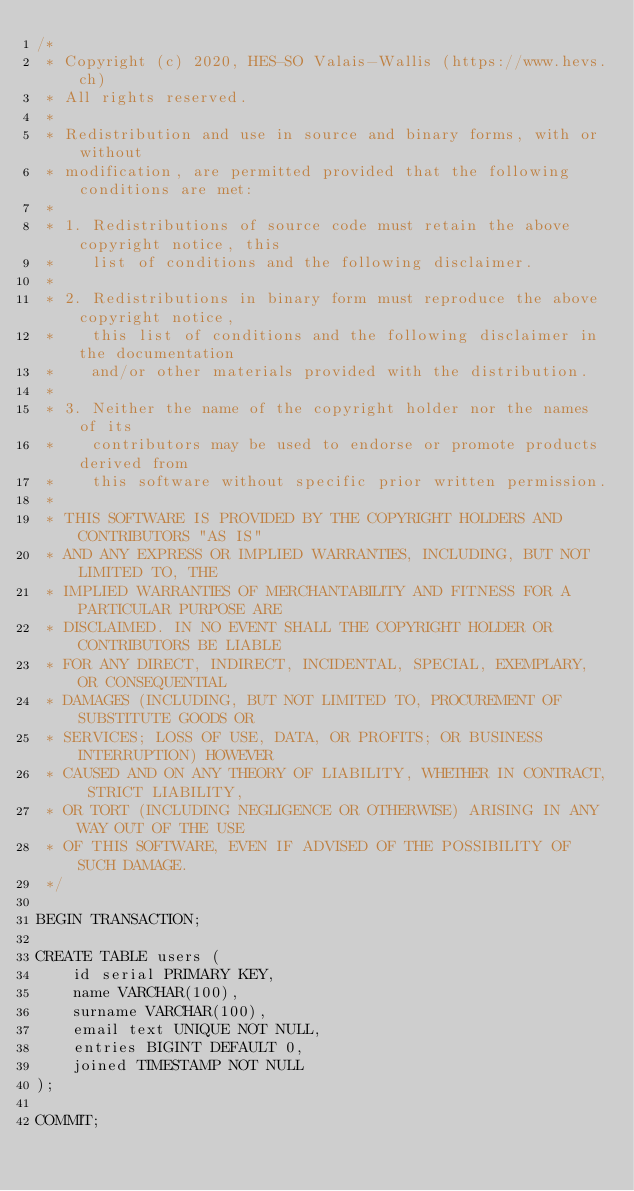<code> <loc_0><loc_0><loc_500><loc_500><_SQL_>/*
 * Copyright (c) 2020, HES-SO Valais-Wallis (https://www.hevs.ch)
 * All rights reserved.
 *
 * Redistribution and use in source and binary forms, with or without
 * modification, are permitted provided that the following conditions are met:
 *
 * 1. Redistributions of source code must retain the above copyright notice, this
 *    list of conditions and the following disclaimer.
 *
 * 2. Redistributions in binary form must reproduce the above copyright notice,
 *    this list of conditions and the following disclaimer in the documentation
 *    and/or other materials provided with the distribution.
 *
 * 3. Neither the name of the copyright holder nor the names of its
 *    contributors may be used to endorse or promote products derived from
 *    this software without specific prior written permission.
 *
 * THIS SOFTWARE IS PROVIDED BY THE COPYRIGHT HOLDERS AND CONTRIBUTORS "AS IS"
 * AND ANY EXPRESS OR IMPLIED WARRANTIES, INCLUDING, BUT NOT LIMITED TO, THE
 * IMPLIED WARRANTIES OF MERCHANTABILITY AND FITNESS FOR A PARTICULAR PURPOSE ARE
 * DISCLAIMED. IN NO EVENT SHALL THE COPYRIGHT HOLDER OR CONTRIBUTORS BE LIABLE
 * FOR ANY DIRECT, INDIRECT, INCIDENTAL, SPECIAL, EXEMPLARY, OR CONSEQUENTIAL
 * DAMAGES (INCLUDING, BUT NOT LIMITED TO, PROCUREMENT OF SUBSTITUTE GOODS OR
 * SERVICES; LOSS OF USE, DATA, OR PROFITS; OR BUSINESS INTERRUPTION) HOWEVER
 * CAUSED AND ON ANY THEORY OF LIABILITY, WHETHER IN CONTRACT, STRICT LIABILITY,
 * OR TORT (INCLUDING NEGLIGENCE OR OTHERWISE) ARISING IN ANY WAY OUT OF THE USE
 * OF THIS SOFTWARE, EVEN IF ADVISED OF THE POSSIBILITY OF SUCH DAMAGE.
 */

BEGIN TRANSACTION;

CREATE TABLE users (
    id serial PRIMARY KEY,
    name VARCHAR(100),
    surname VARCHAR(100),
    email text UNIQUE NOT NULL,
    entries BIGINT DEFAULT 0,
    joined TIMESTAMP NOT NULL
);

COMMIT;</code> 